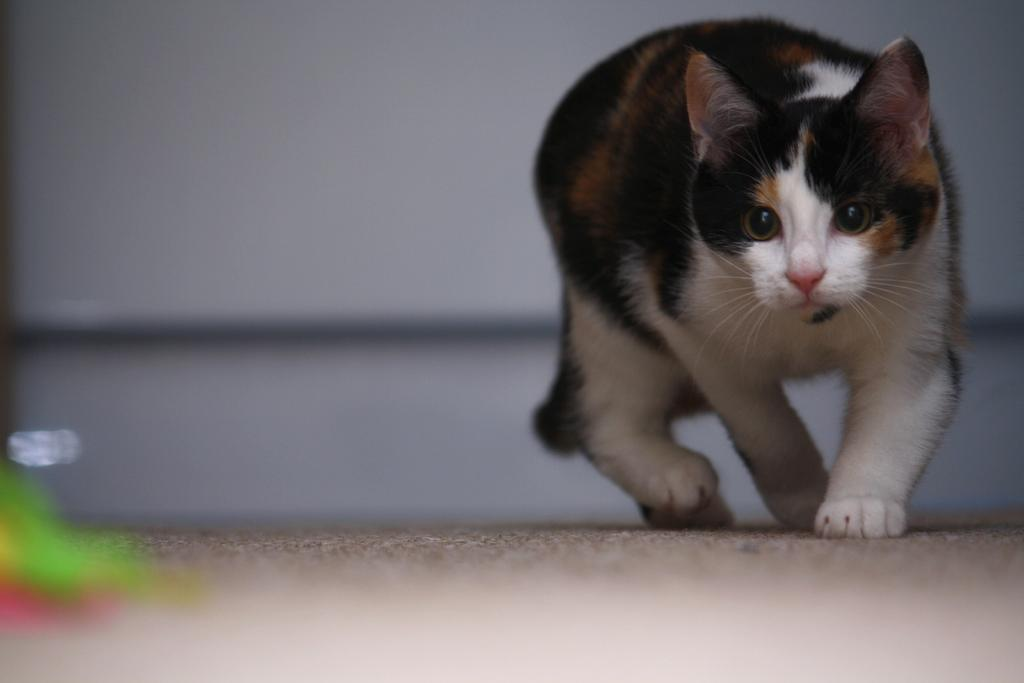What animal is present in the image? There is a cat in the image. What is the cat doing in the image? The cat is walking on the ground. Can you describe the background of the image? The background of the image is blurry. How many frogs are jumping in the image? There are no frogs present in the image; it features a cat walking on the ground. What type of beef is being served in the image? There is no beef present in the image. 